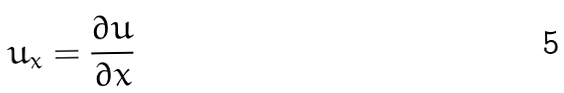<formula> <loc_0><loc_0><loc_500><loc_500>u _ { x } = \frac { \partial u } { \partial x }</formula> 